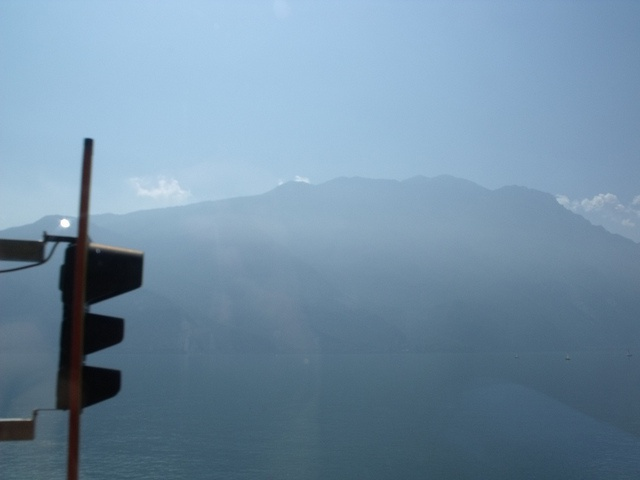Describe the objects in this image and their specific colors. I can see a traffic light in lightblue, black, gray, and darkblue tones in this image. 